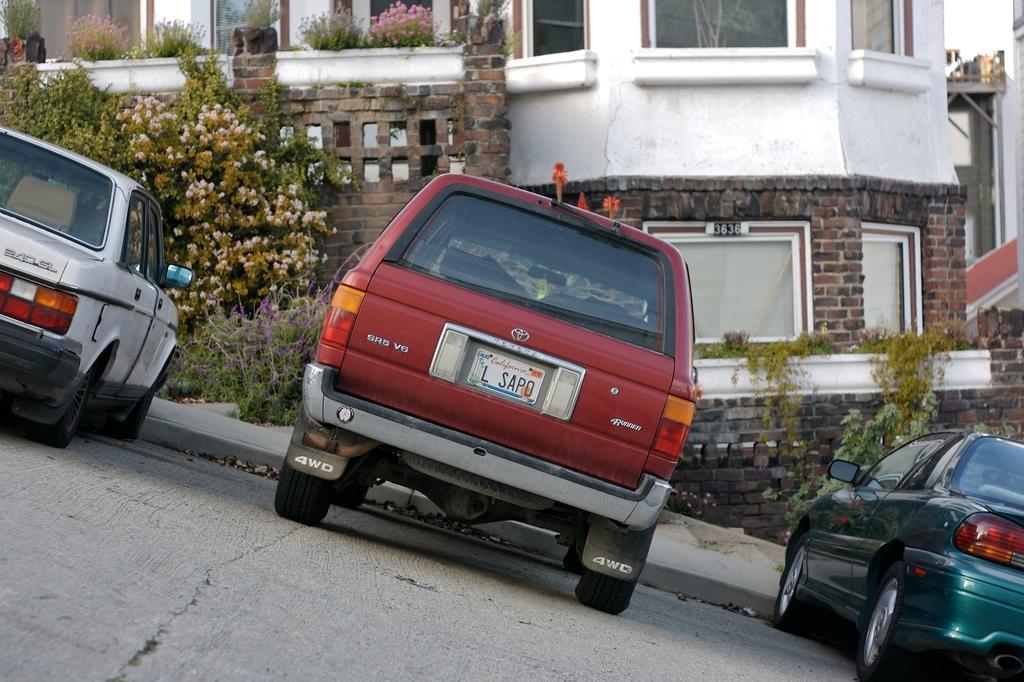In one or two sentences, can you explain what this image depicts? In this image there are cars on a road, in the background there are plants and a building. 